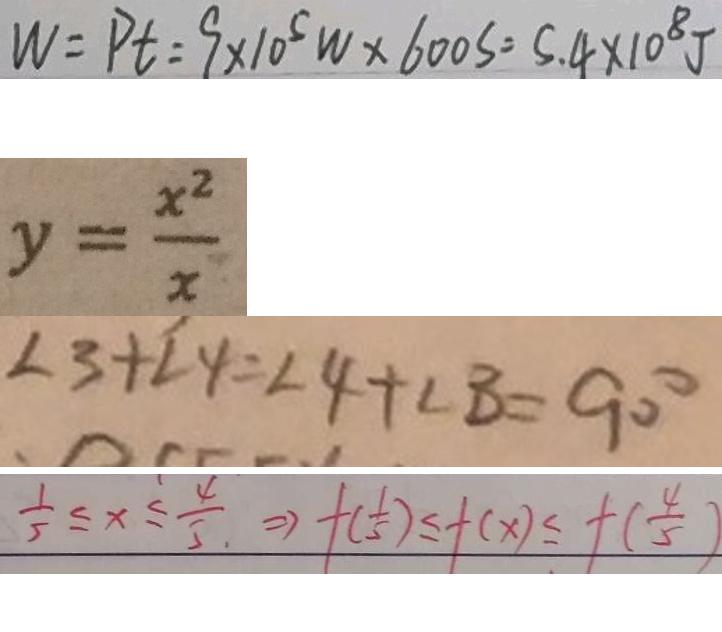<formula> <loc_0><loc_0><loc_500><loc_500>W = P t = 9 \times 1 0 ^ { 5 } w \times 6 0 0 s = 5 . 4 \times 1 0 ^ { 8 } J 
 y = \frac { x ^ { 2 } } { x } 
 \angle 3 + \angle 4 = \angle 4 + \angle B = 9 0 ^ { \circ } 
 \frac { 1 } { 5 } \leq x \leq \frac { 4 } { 5 } \Rightarrow f ( \frac { 1 } { 5 } ) \leq f ( x ) \leq f ( \frac { 4 } { 5 } )</formula> 